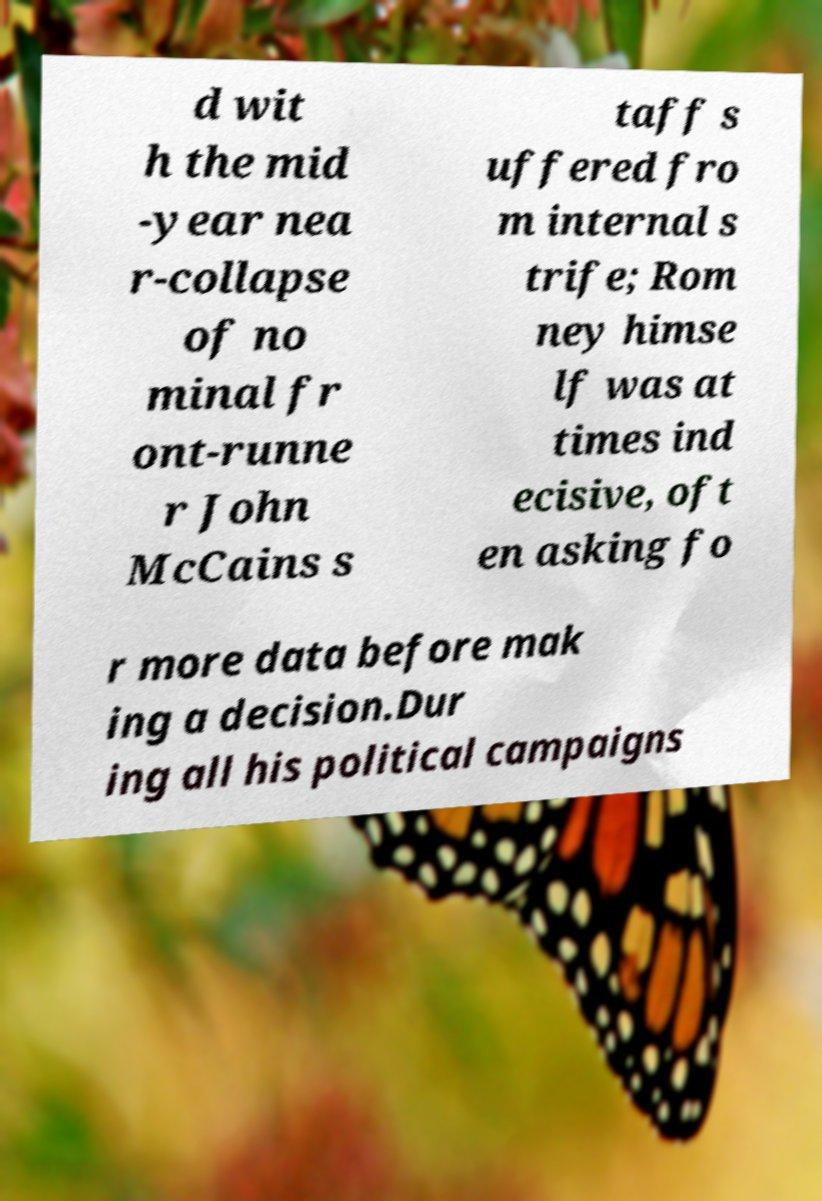Please identify and transcribe the text found in this image. d wit h the mid -year nea r-collapse of no minal fr ont-runne r John McCains s taff s uffered fro m internal s trife; Rom ney himse lf was at times ind ecisive, oft en asking fo r more data before mak ing a decision.Dur ing all his political campaigns 